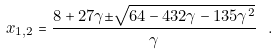Convert formula to latex. <formula><loc_0><loc_0><loc_500><loc_500>x _ { 1 , 2 } = \frac { 8 + 2 7 \gamma { \pm } \sqrt { 6 4 - 4 3 2 \gamma - 1 3 5 \gamma ^ { 2 } } } { \gamma } \ .</formula> 